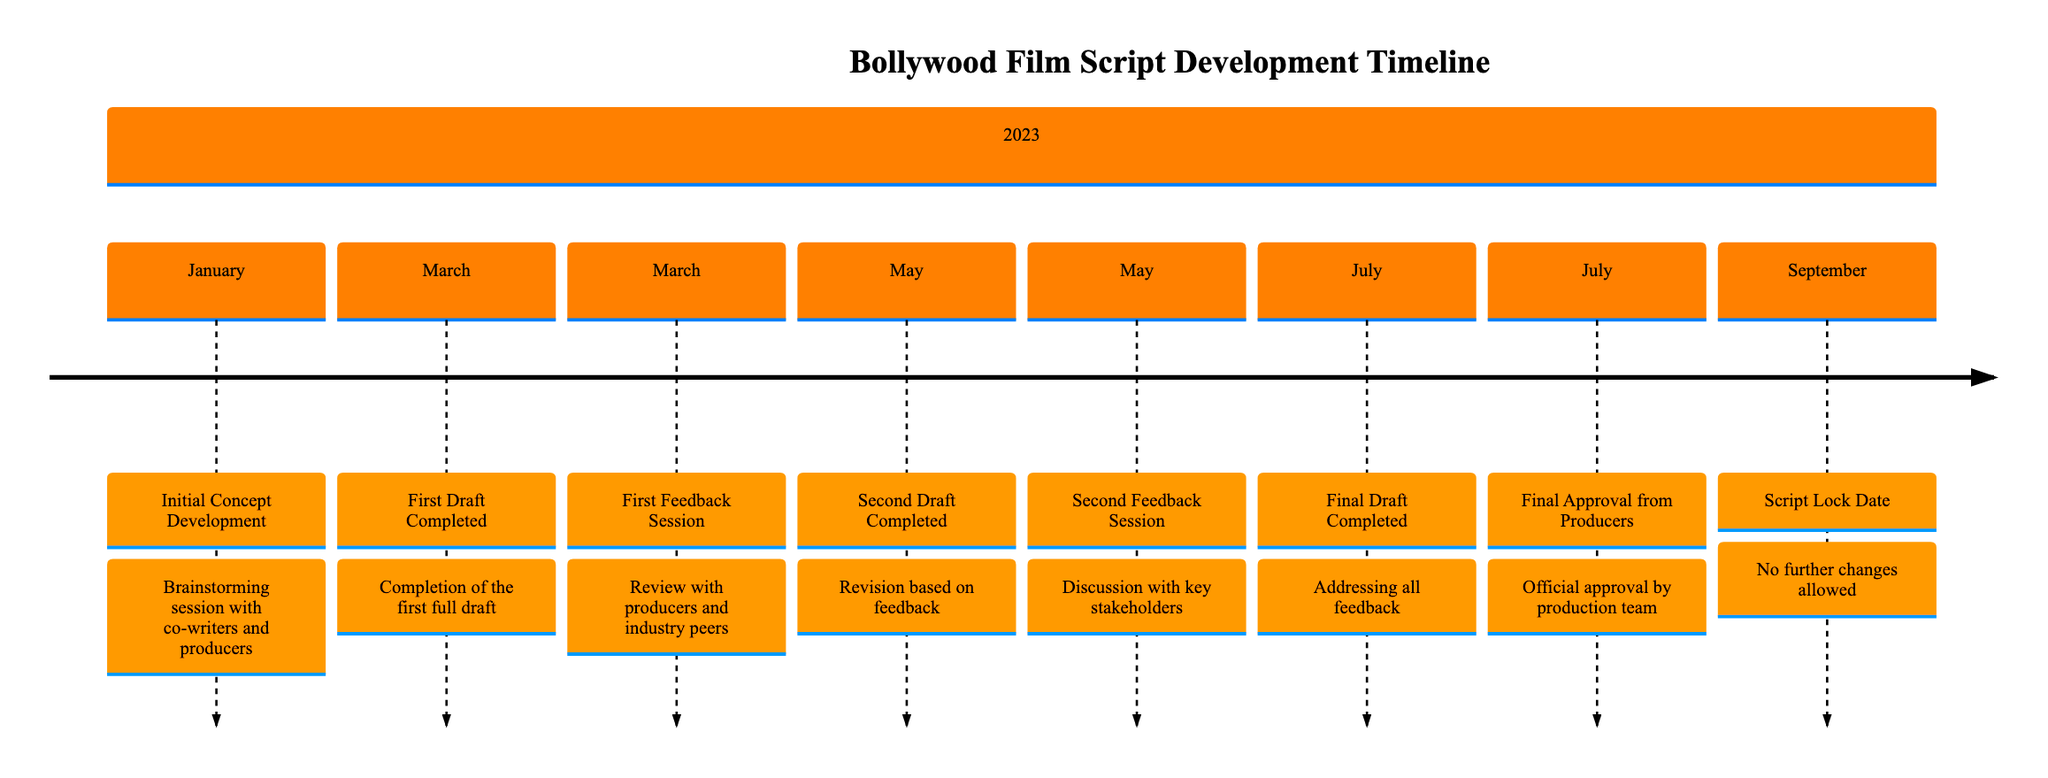What is the date of the First Draft Completed? The diagram indicates that the milestone "First Draft Completed" is set for March 15, 2023.
Answer: March 15, 2023 How many feedback sessions are included in the timeline? The timeline shows two distinct feedback sessions, one after the first draft and another after the second draft.
Answer: 2 What milestone directly follows the Second Draft Completed? According to the timeline, the "Second Feedback Session" occurs right after the "Second Draft Completed" milestone in May.
Answer: Second Feedback Session Which draft came after the First Feedback Session? The timeline indicates that the "Second Draft Completed" is the next milestone that follows the "First Feedback Session."
Answer: Second Draft Completed What is the final milestone before the Script Lock Date? The diagram shows that "Final Approval from Producers" is the last milestone prior to the "Script Lock Date" occurring in September.
Answer: Final Approval from Producers When was the Final Draft Completed? The timeline states that the "Final Draft Completed" milestone is marked on July 1, 2023.
Answer: July 1, 2023 What key activity is associated with the milestone dated May 15? The milestone dated May 15 is associated with the "Second Feedback Session" where key stakeholders discussed the script.
Answer: Second Feedback Session How much time elapsed between the First Draft Completed and the Final Draft Completed? The timeline shows the First Draft was completed on March 15 and the Final Draft on July 1, which is a period of about 3 months and 16 days.
Answer: About 3 months and 16 days What is the purpose of the milestone named Script Lock Date? The milestone "Script Lock Date" signifies that no further changes are allowed as the film enters pre-production stages.
Answer: No further changes allowed 